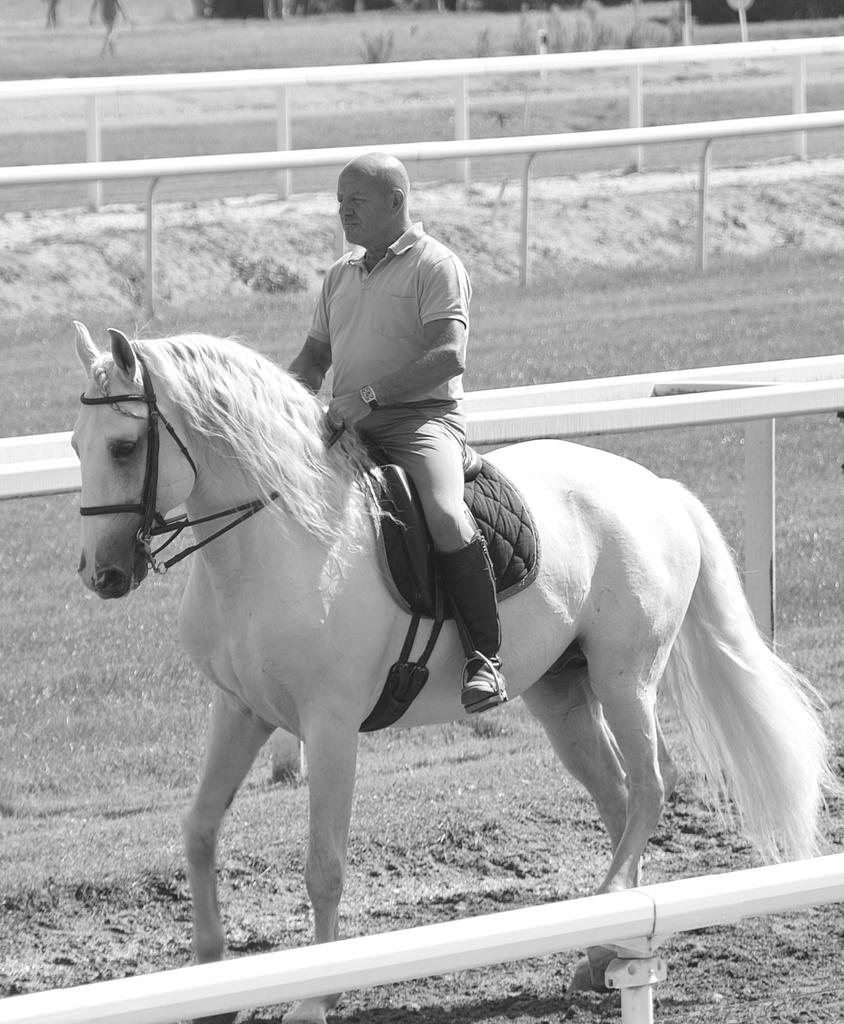Who or what is the main subject in the image? There is a person in the image. What is the person doing in the image? The person is sitting on a horse and riding it. What type of pipe can be seen being played by the person in the image? There is no pipe present in the image; the person is riding a horse. How many marbles can be seen rolling on the ground in the image? There are no marbles present in the image. 